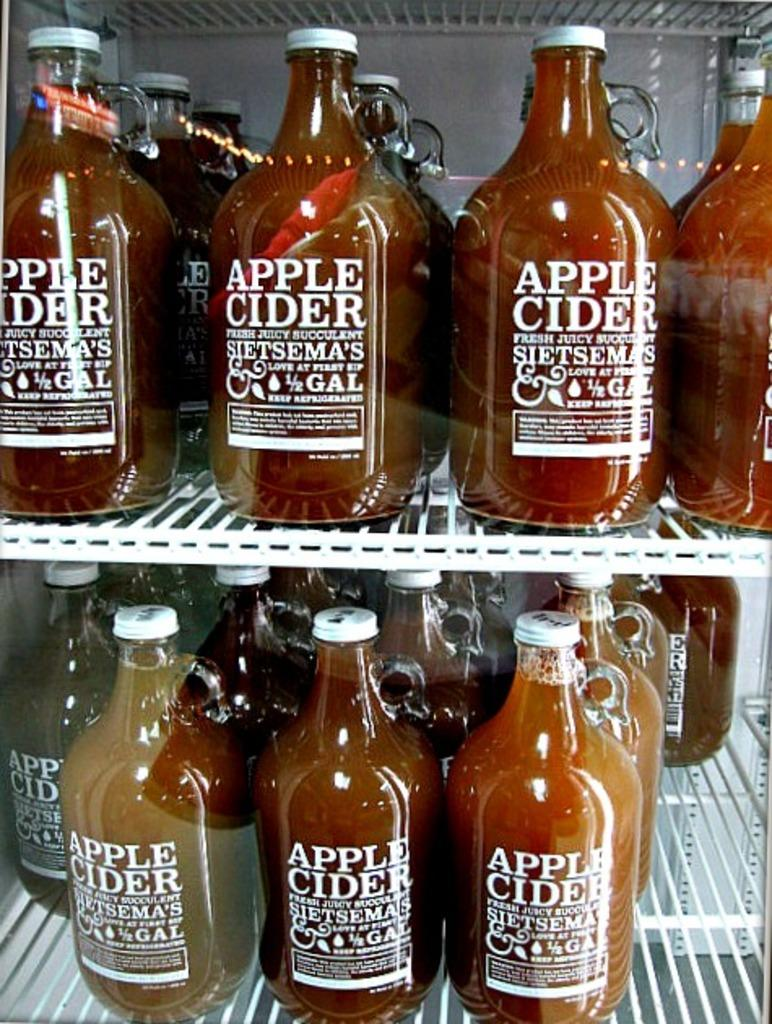<image>
Summarize the visual content of the image. A large walk in fridge is full of large bottles of Sietsema's Apple Cider. 